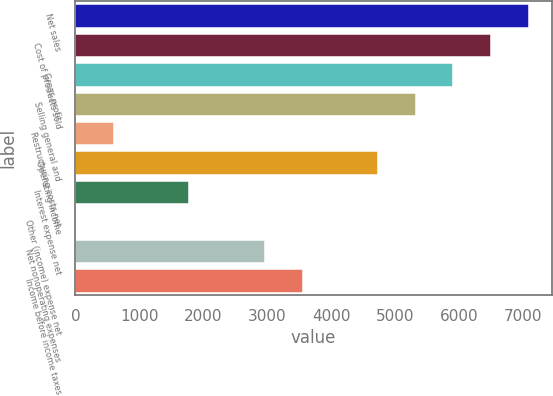Convert chart. <chart><loc_0><loc_0><loc_500><loc_500><bar_chart><fcel>Net sales<fcel>Cost of products sold<fcel>Gross profit<fcel>Selling general and<fcel>Restructuring costs net<fcel>Operating income<fcel>Interest expense net<fcel>Other (income) expense net<fcel>Net nonoperating expenses<fcel>Income before income taxes<nl><fcel>7096.58<fcel>6506.14<fcel>5915.7<fcel>5325.26<fcel>601.74<fcel>4734.82<fcel>1782.62<fcel>11.3<fcel>2963.5<fcel>3553.94<nl></chart> 